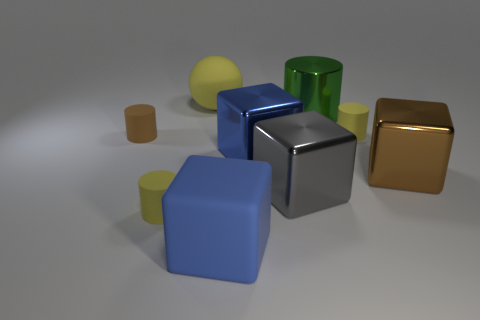Add 1 large brown shiny things. How many objects exist? 10 Subtract all cylinders. How many objects are left? 5 Add 8 big cylinders. How many big cylinders are left? 9 Add 5 small green matte cylinders. How many small green matte cylinders exist? 5 Subtract 0 cyan cylinders. How many objects are left? 9 Subtract all large yellow matte things. Subtract all cyan objects. How many objects are left? 8 